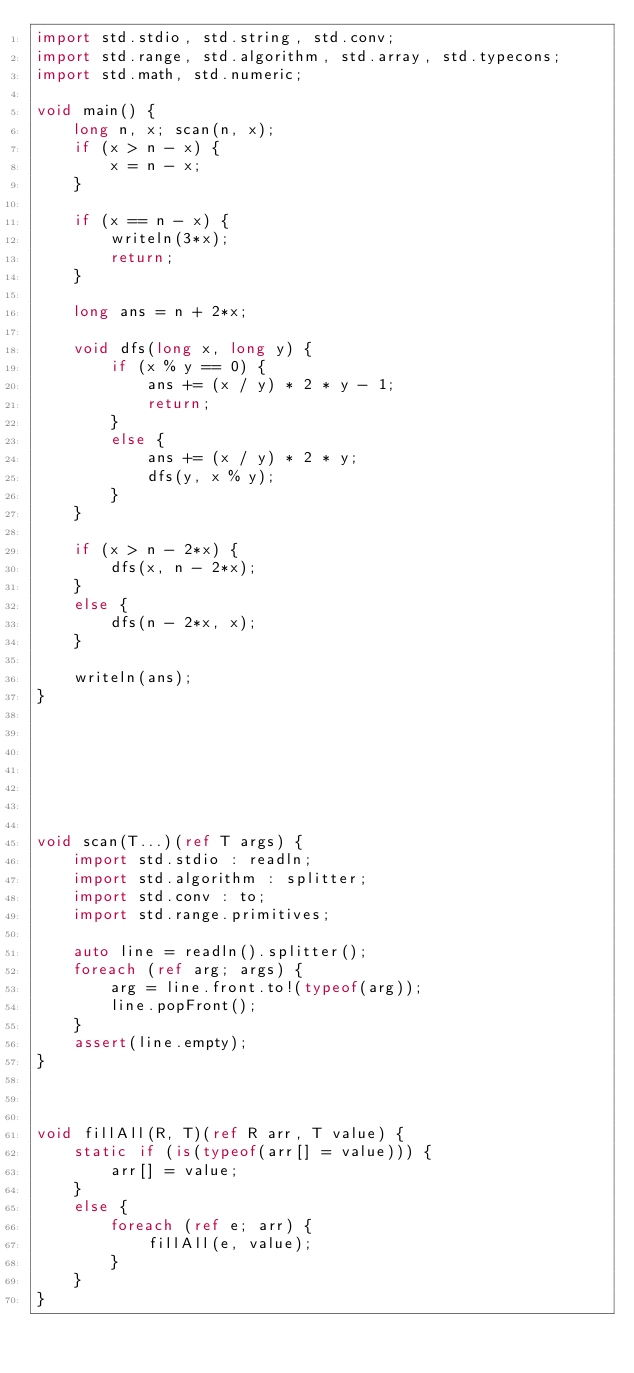<code> <loc_0><loc_0><loc_500><loc_500><_D_>import std.stdio, std.string, std.conv;
import std.range, std.algorithm, std.array, std.typecons;
import std.math, std.numeric;

void main() {
    long n, x; scan(n, x);
    if (x > n - x) {
        x = n - x;
    }

    if (x == n - x) {
        writeln(3*x);
        return;
    }

    long ans = n + 2*x;

    void dfs(long x, long y) {
        if (x % y == 0) {
            ans += (x / y) * 2 * y - 1;
            return;
        }
        else {
            ans += (x / y) * 2 * y;
            dfs(y, x % y);
        }
    }

    if (x > n - 2*x) {
        dfs(x, n - 2*x);
    }
    else {
        dfs(n - 2*x, x);
    }

    writeln(ans);
}







void scan(T...)(ref T args) {
    import std.stdio : readln;
    import std.algorithm : splitter;
    import std.conv : to;
    import std.range.primitives;

    auto line = readln().splitter();
    foreach (ref arg; args) {
        arg = line.front.to!(typeof(arg));
        line.popFront();
    }
    assert(line.empty);
}



void fillAll(R, T)(ref R arr, T value) {
    static if (is(typeof(arr[] = value))) {
        arr[] = value;
    }
    else {
        foreach (ref e; arr) {
            fillAll(e, value);
        }
    }
}
</code> 